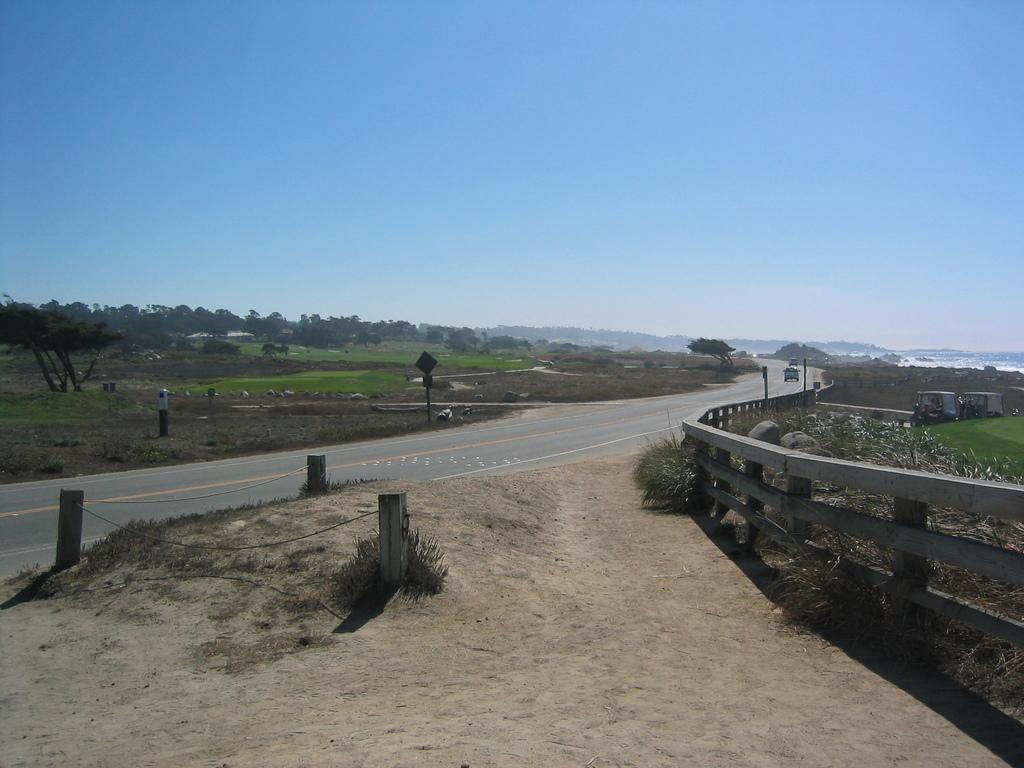What can be seen on the road in the image? There are motor vehicles on the road in the image. What type of informational or directional signs are present in the image? There are sign boards in the image. What might be used to separate or protect certain areas in the image? Barrier poles are present in the image. What type of vegetation is visible in the image? Shrubs, bushes, grass, and trees are visible in the image. What natural element is present in the image? Water is visible in the image. What type of terrain feature is present in the image? Rocks are present in the image. What part of the natural environment is visible in the image? The sky is visible in the image. What type of suit is the monkey wearing in the image? There is no monkey present in the image, and therefore no suit can be observed. How does the pollution affect the image? The provided facts do not mention any pollution, so it cannot be determined how it might affect the image. 